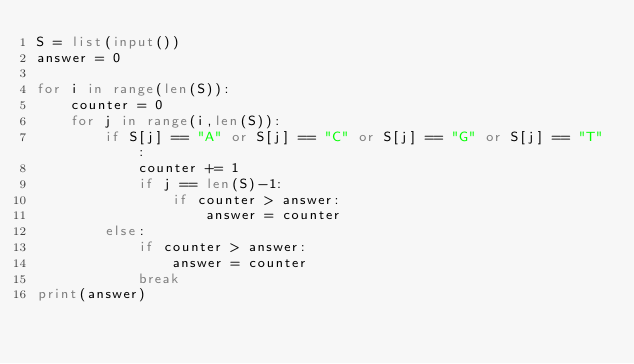<code> <loc_0><loc_0><loc_500><loc_500><_Python_>S = list(input())
answer = 0

for i in range(len(S)):
    counter = 0
    for j in range(i,len(S)):
        if S[j] == "A" or S[j] == "C" or S[j] == "G" or S[j] == "T":
            counter += 1  
            if j == len(S)-1:
                if counter > answer:
                    answer = counter
        else:
            if counter > answer:
                answer = counter
            break
print(answer)</code> 